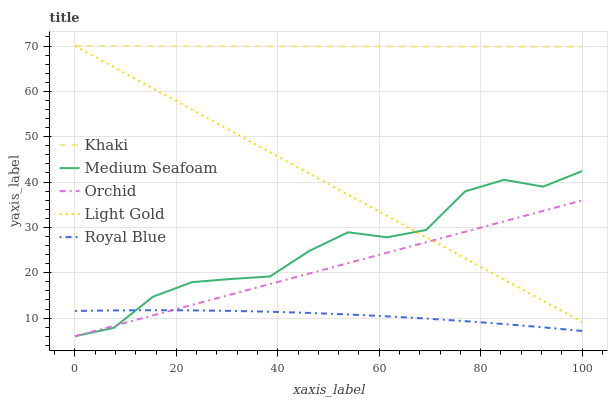Does Royal Blue have the minimum area under the curve?
Answer yes or no. Yes. Does Khaki have the maximum area under the curve?
Answer yes or no. Yes. Does Light Gold have the minimum area under the curve?
Answer yes or no. No. Does Light Gold have the maximum area under the curve?
Answer yes or no. No. Is Light Gold the smoothest?
Answer yes or no. Yes. Is Medium Seafoam the roughest?
Answer yes or no. Yes. Is Khaki the smoothest?
Answer yes or no. No. Is Khaki the roughest?
Answer yes or no. No. Does Medium Seafoam have the lowest value?
Answer yes or no. Yes. Does Light Gold have the lowest value?
Answer yes or no. No. Does Light Gold have the highest value?
Answer yes or no. Yes. Does Medium Seafoam have the highest value?
Answer yes or no. No. Is Royal Blue less than Light Gold?
Answer yes or no. Yes. Is Khaki greater than Royal Blue?
Answer yes or no. Yes. Does Orchid intersect Royal Blue?
Answer yes or no. Yes. Is Orchid less than Royal Blue?
Answer yes or no. No. Is Orchid greater than Royal Blue?
Answer yes or no. No. Does Royal Blue intersect Light Gold?
Answer yes or no. No. 